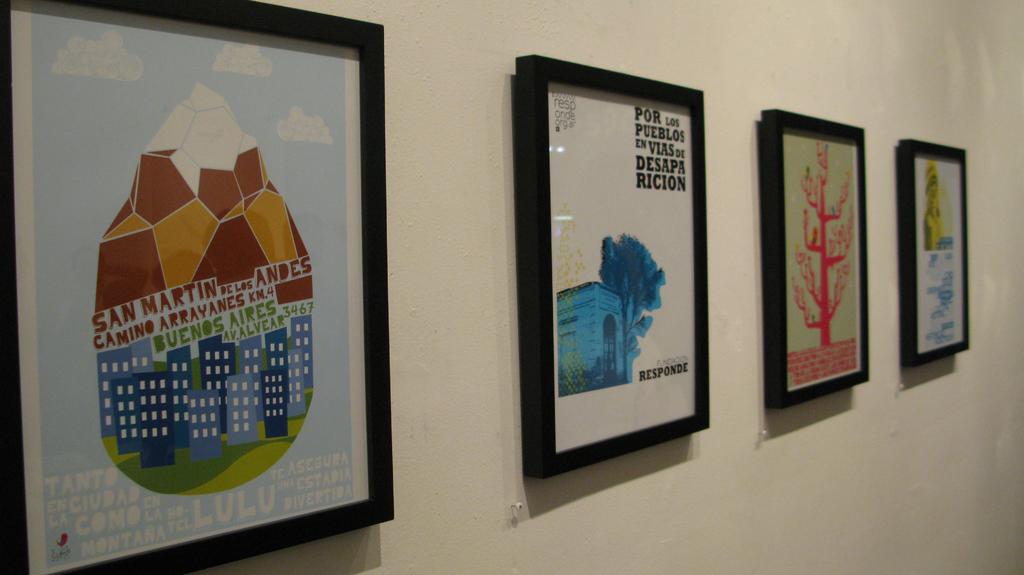What comes after san on the first picture?
Provide a short and direct response. Martin. 